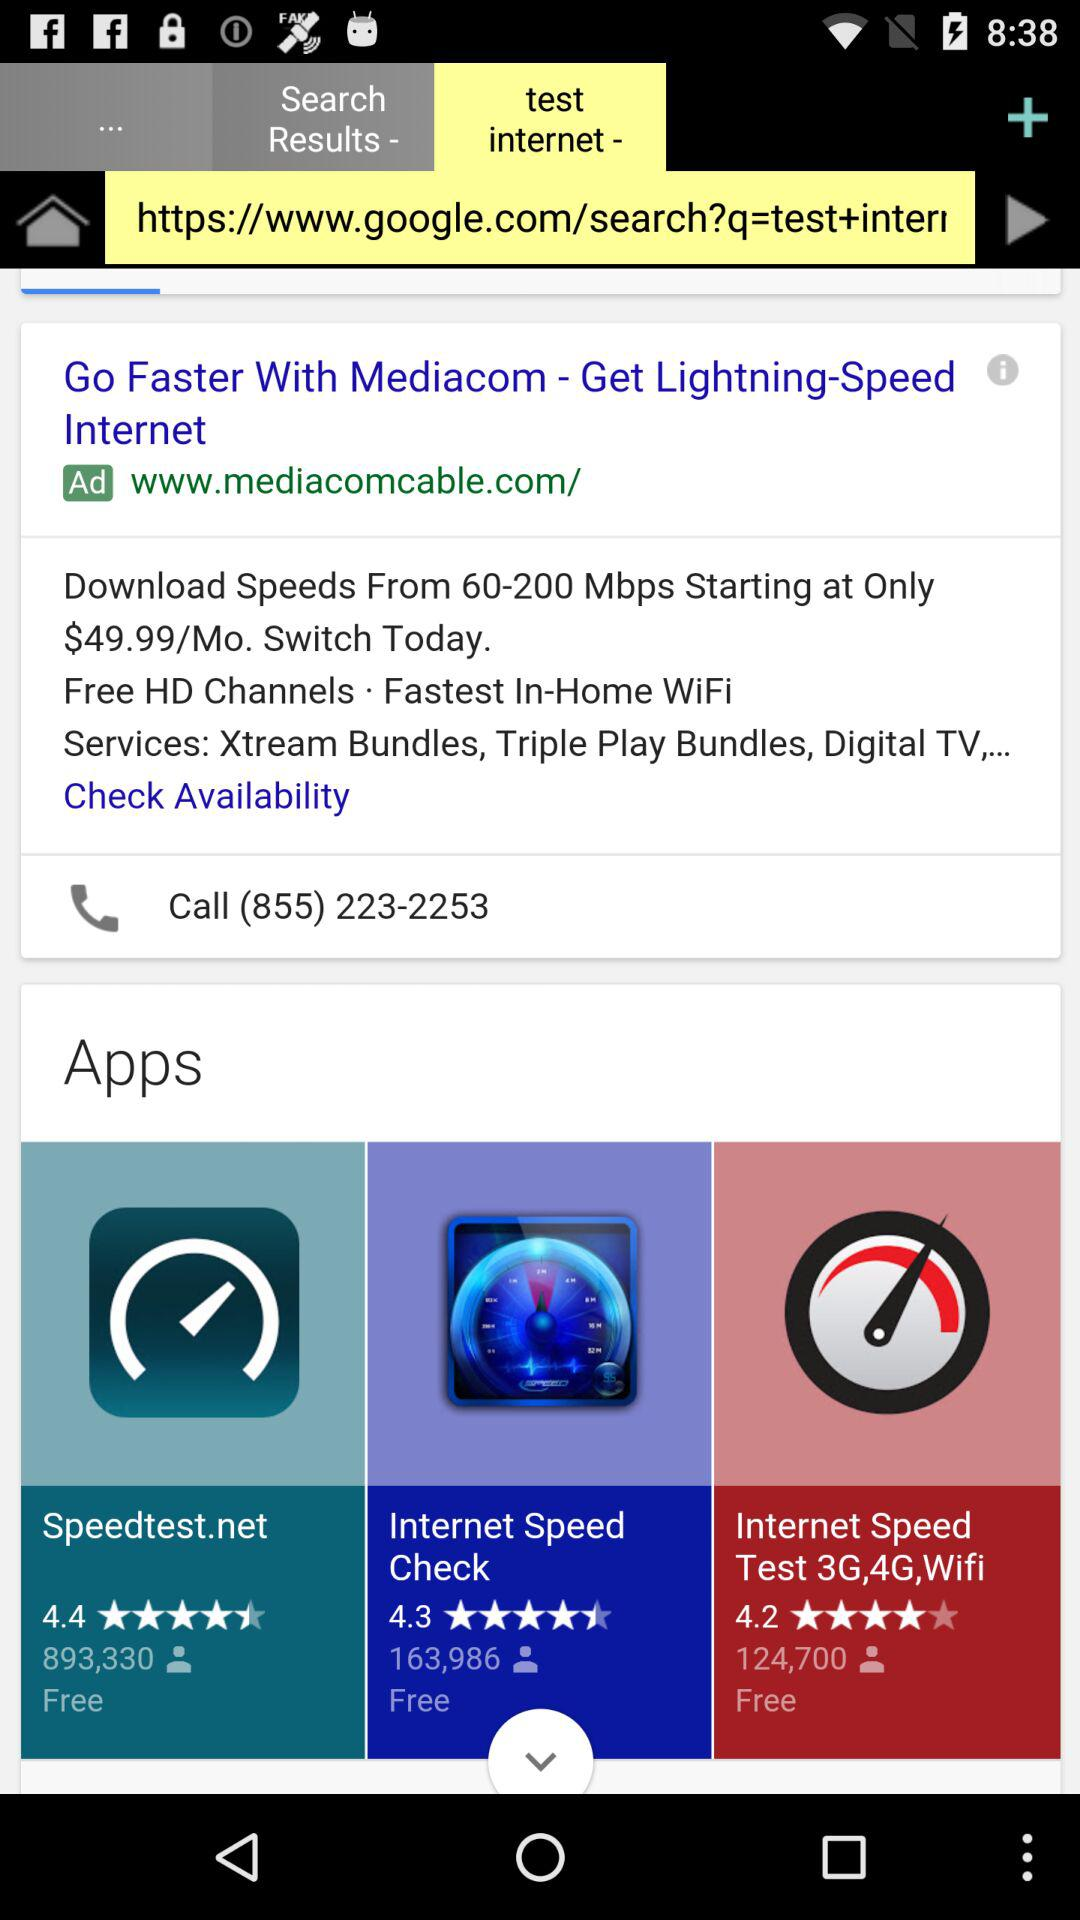How many people have reviewed "Speedtest.net"? There are 893,330 people who have reviewed "Speedtest.net". 